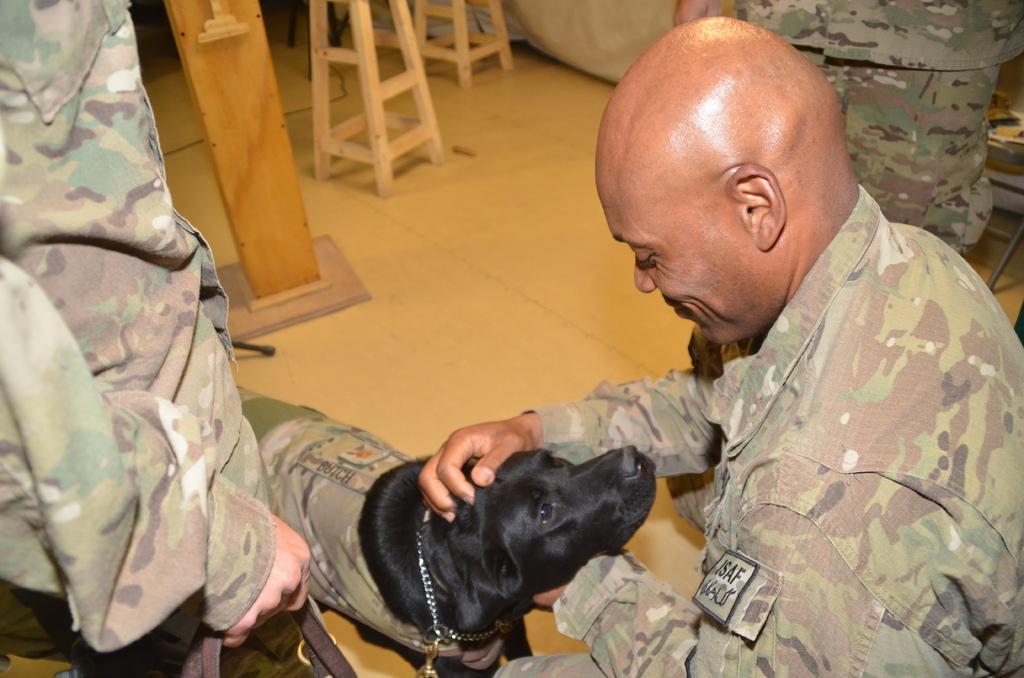Can you describe this image briefly? This man is looking at this black dog. Here we can see people and wooden objects. These people wore military dress. 